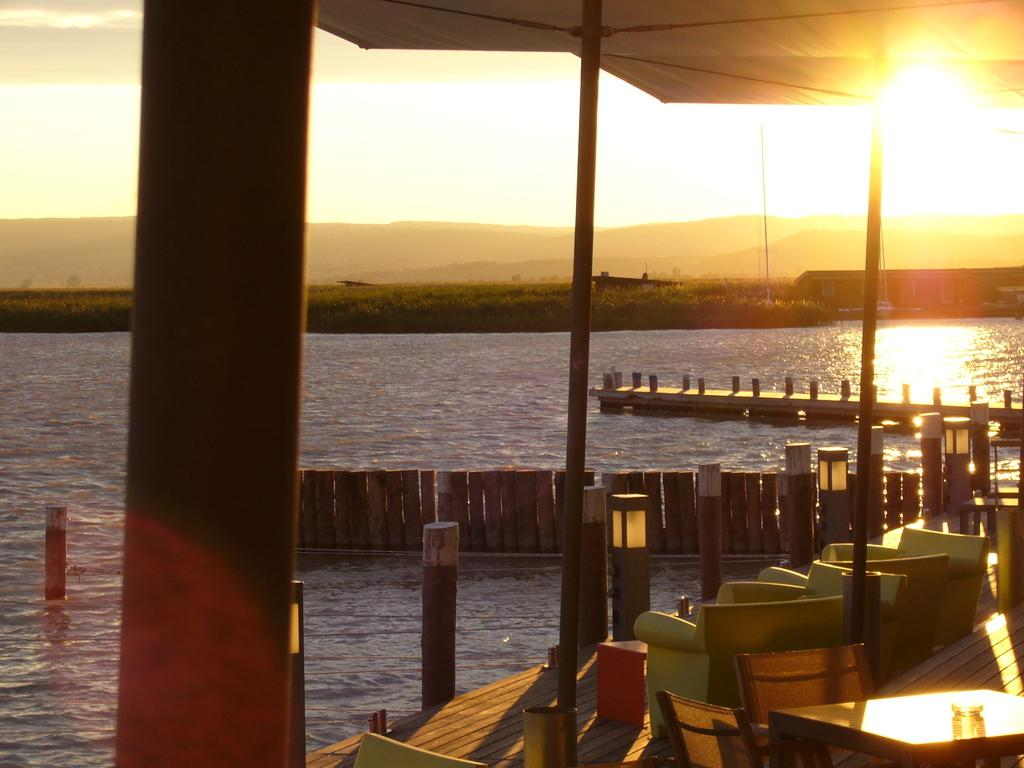What is the main subject of the image? The main subject of the image is a boat. What can be found inside the boat? There are chairs in the boat. What type of material is used for the railing in the background? The railing in the background is made of wood. What type of vegetation is visible in the background? Grass is visible in the background. What is the color of the sky in the image? The sky is white in color. How does the boat compare to a washing machine in the image? There is no washing machine present in the image, so it cannot be compared to the boat. 